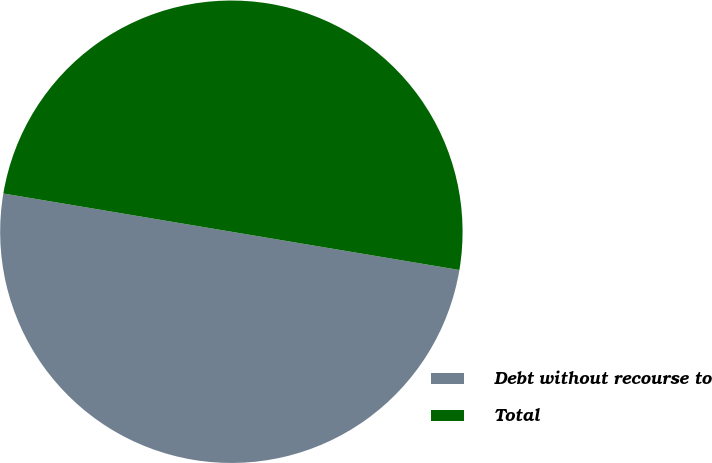<chart> <loc_0><loc_0><loc_500><loc_500><pie_chart><fcel>Debt without recourse to<fcel>Total<nl><fcel>50.0%<fcel>50.0%<nl></chart> 